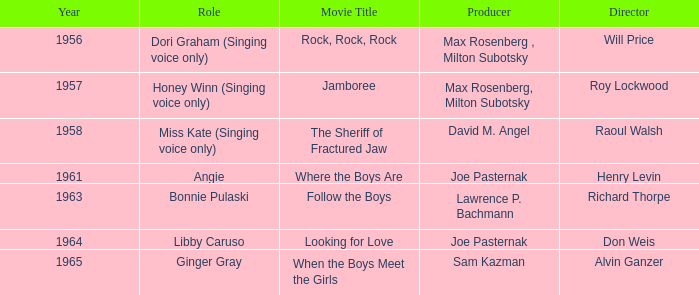What year was Sam Kazman a producer? 1965.0. Can you parse all the data within this table? {'header': ['Year', 'Role', 'Movie Title', 'Producer', 'Director'], 'rows': [['1956', 'Dori Graham (Singing voice only)', 'Rock, Rock, Rock', 'Max Rosenberg , Milton Subotsky', 'Will Price'], ['1957', 'Honey Winn (Singing voice only)', 'Jamboree', 'Max Rosenberg, Milton Subotsky', 'Roy Lockwood'], ['1958', 'Miss Kate (Singing voice only)', 'The Sheriff of Fractured Jaw', 'David M. Angel', 'Raoul Walsh'], ['1961', 'Angie', 'Where the Boys Are', 'Joe Pasternak', 'Henry Levin'], ['1963', 'Bonnie Pulaski', 'Follow the Boys', 'Lawrence P. Bachmann', 'Richard Thorpe'], ['1964', 'Libby Caruso', 'Looking for Love', 'Joe Pasternak', 'Don Weis'], ['1965', 'Ginger Gray', 'When the Boys Meet the Girls', 'Sam Kazman', 'Alvin Ganzer']]} 